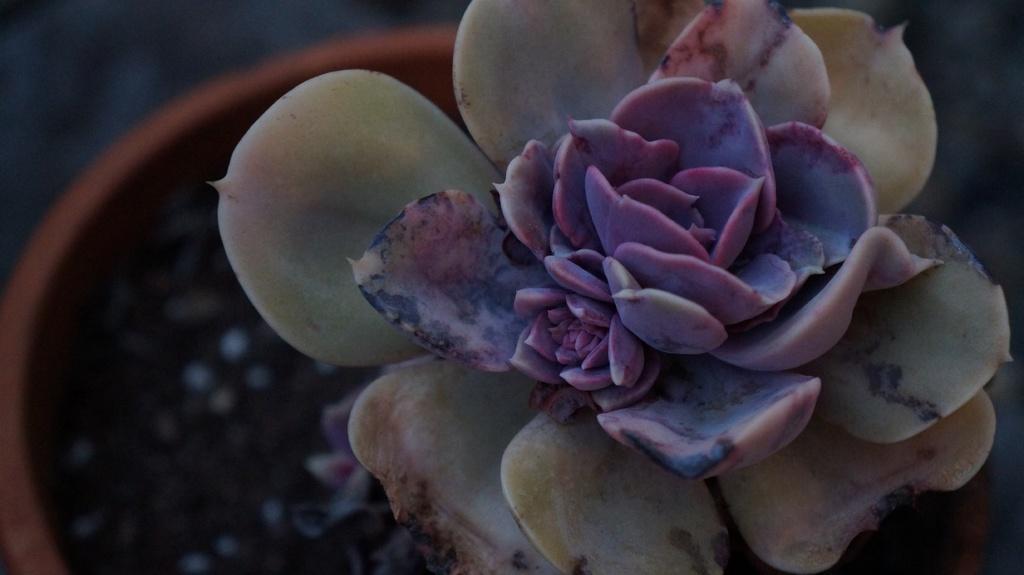Please provide a concise description of this image. In this image we can see a plant. 